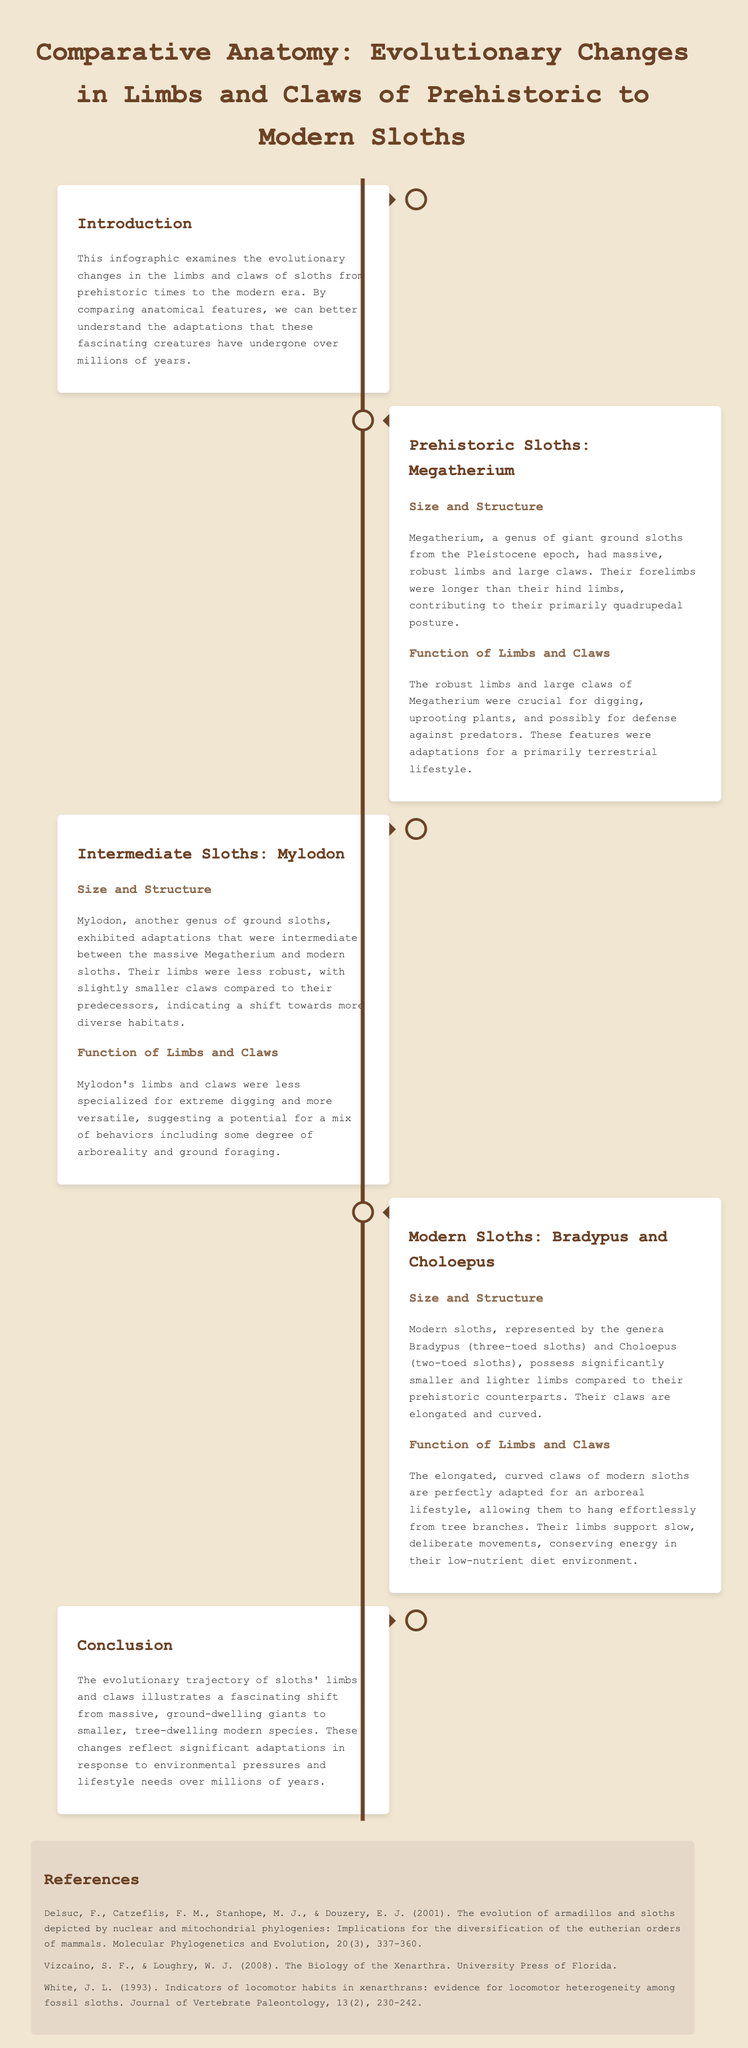What is the title of the infographic? The title of the infographic is stated clearly at the top.
Answer: Comparative Anatomy: Evolutionary Changes in Limbs and Claws of Prehistoric to Modern Sloths What genus of giant ground sloths is mentioned? This genus is described in the section dedicated to prehistoric sloths.
Answer: Megatherium What type of limbs did modern sloths have? This characteristic is described in the section regarding modern sloths.
Answer: Smaller and lighter Which modern sloth genus has three toes? This detail is included in the description of modern sloths.
Answer: Bradypus What type of habitat did Mylodon adapt to? The section on intermediate sloths discusses this aspect of Mylodon's adaptations.
Answer: Diverse habitats How many references are included in the document? The number of references is counted from the references section.
Answer: Three What evolutionary change is illustrated in the conclusion? This change is summarized at the end of the infographic.
Answer: Shift from massive to smaller tree-dwelling species What were Megatherium's claws specialized for? The function of claws is discussed in relation to Megatherium.
Answer: Digging and uprooting plants What adaptation do modern sloths' claws exhibit? This adaptation is mentioned in the context of their lifestyle.
Answer: Elongated and curved What era do the prehistoric sloths belong to? The era is specified in the description of Megatherium.
Answer: Pleistocene epoch 